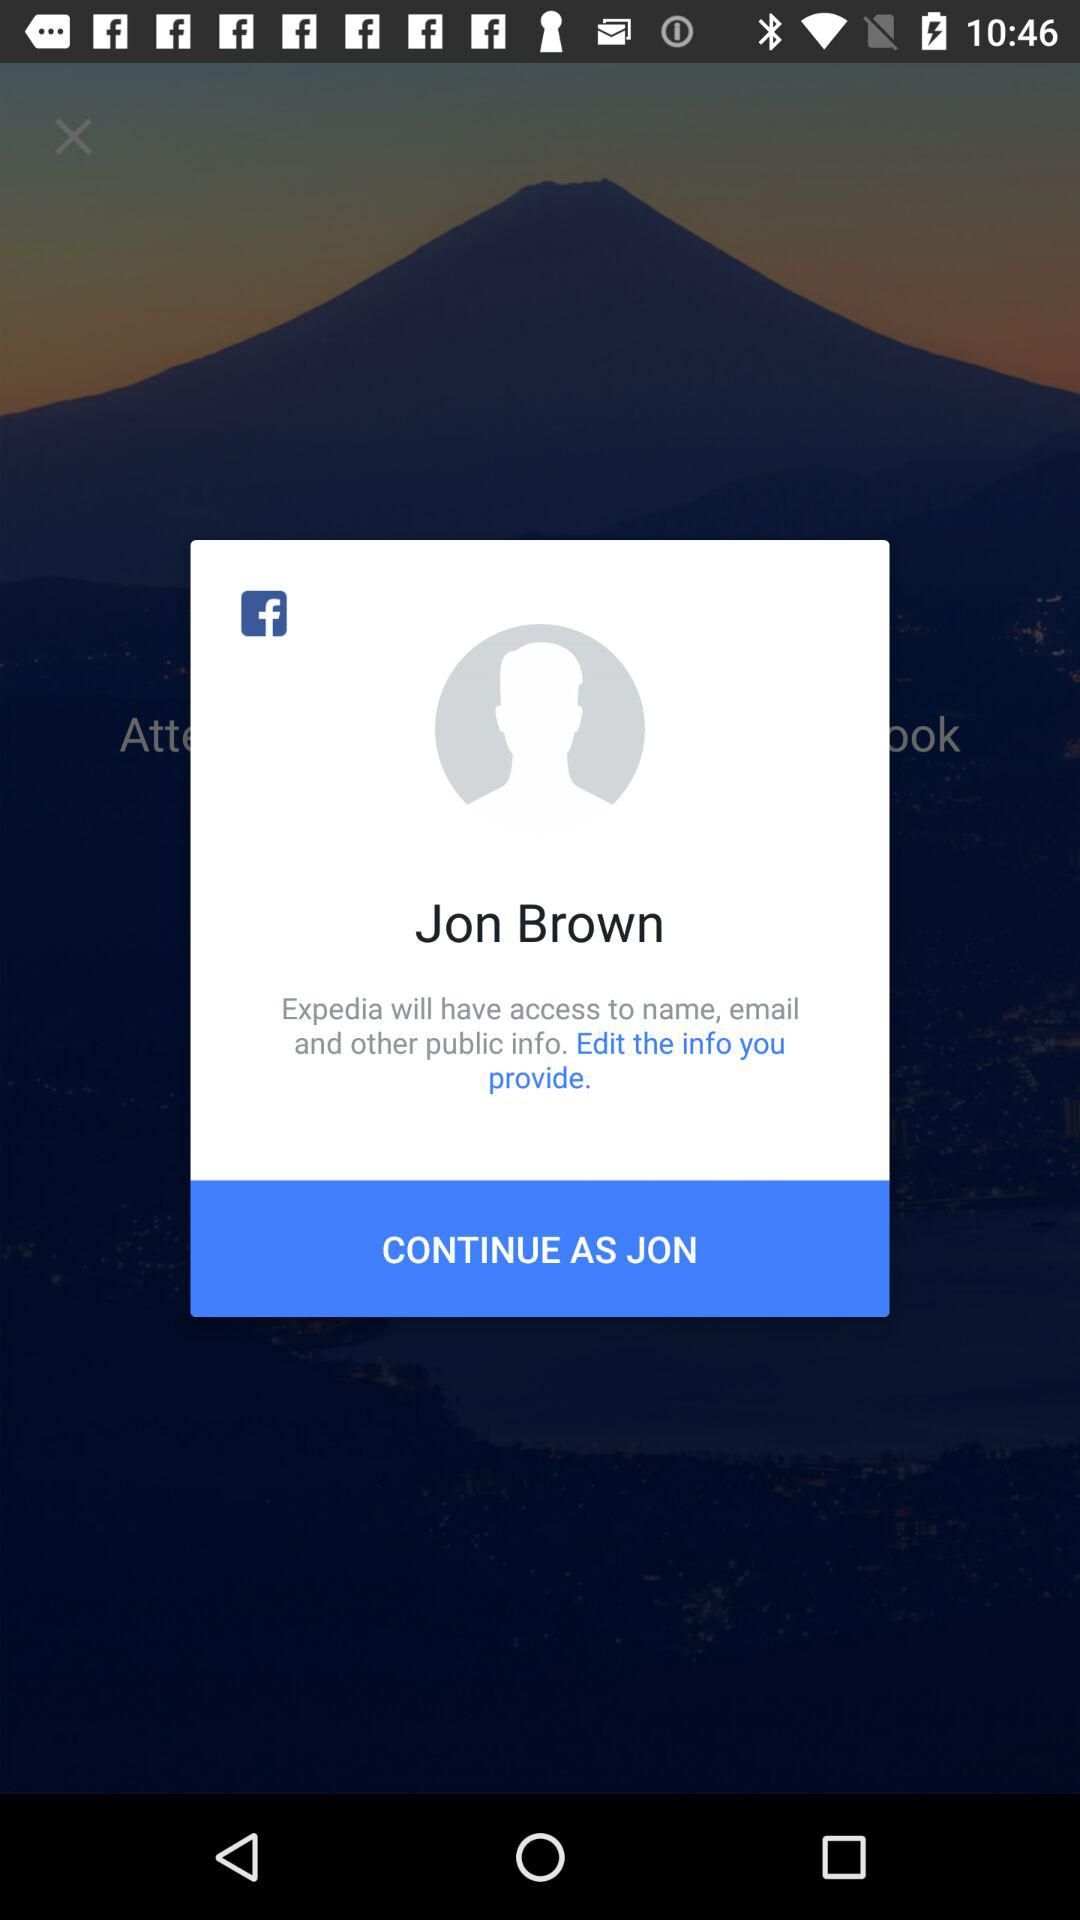What application is asking for permission? The application that is asking for permission is "Expedia". 